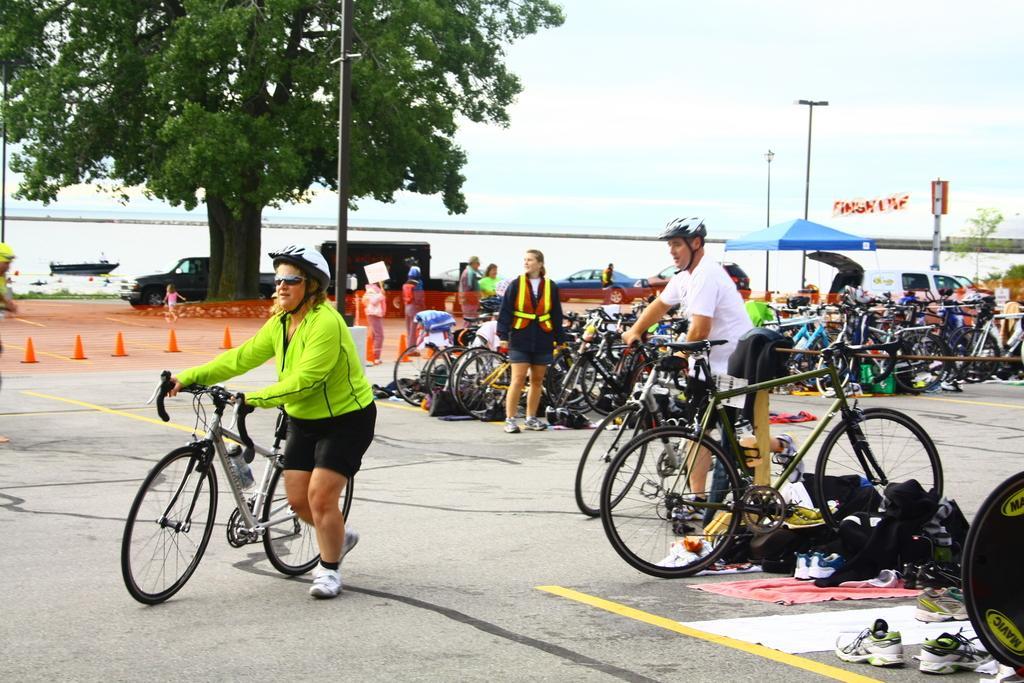Can you describe this image briefly? In this image, there are a few people. We can see some bicycles and vehicles. We can see the ground with some objects. We can also see some pairs of shoes. There are a few poles, a tree and an umbrella. We can also see some water and a boat sailing on it. We can see the wall and the sky. 